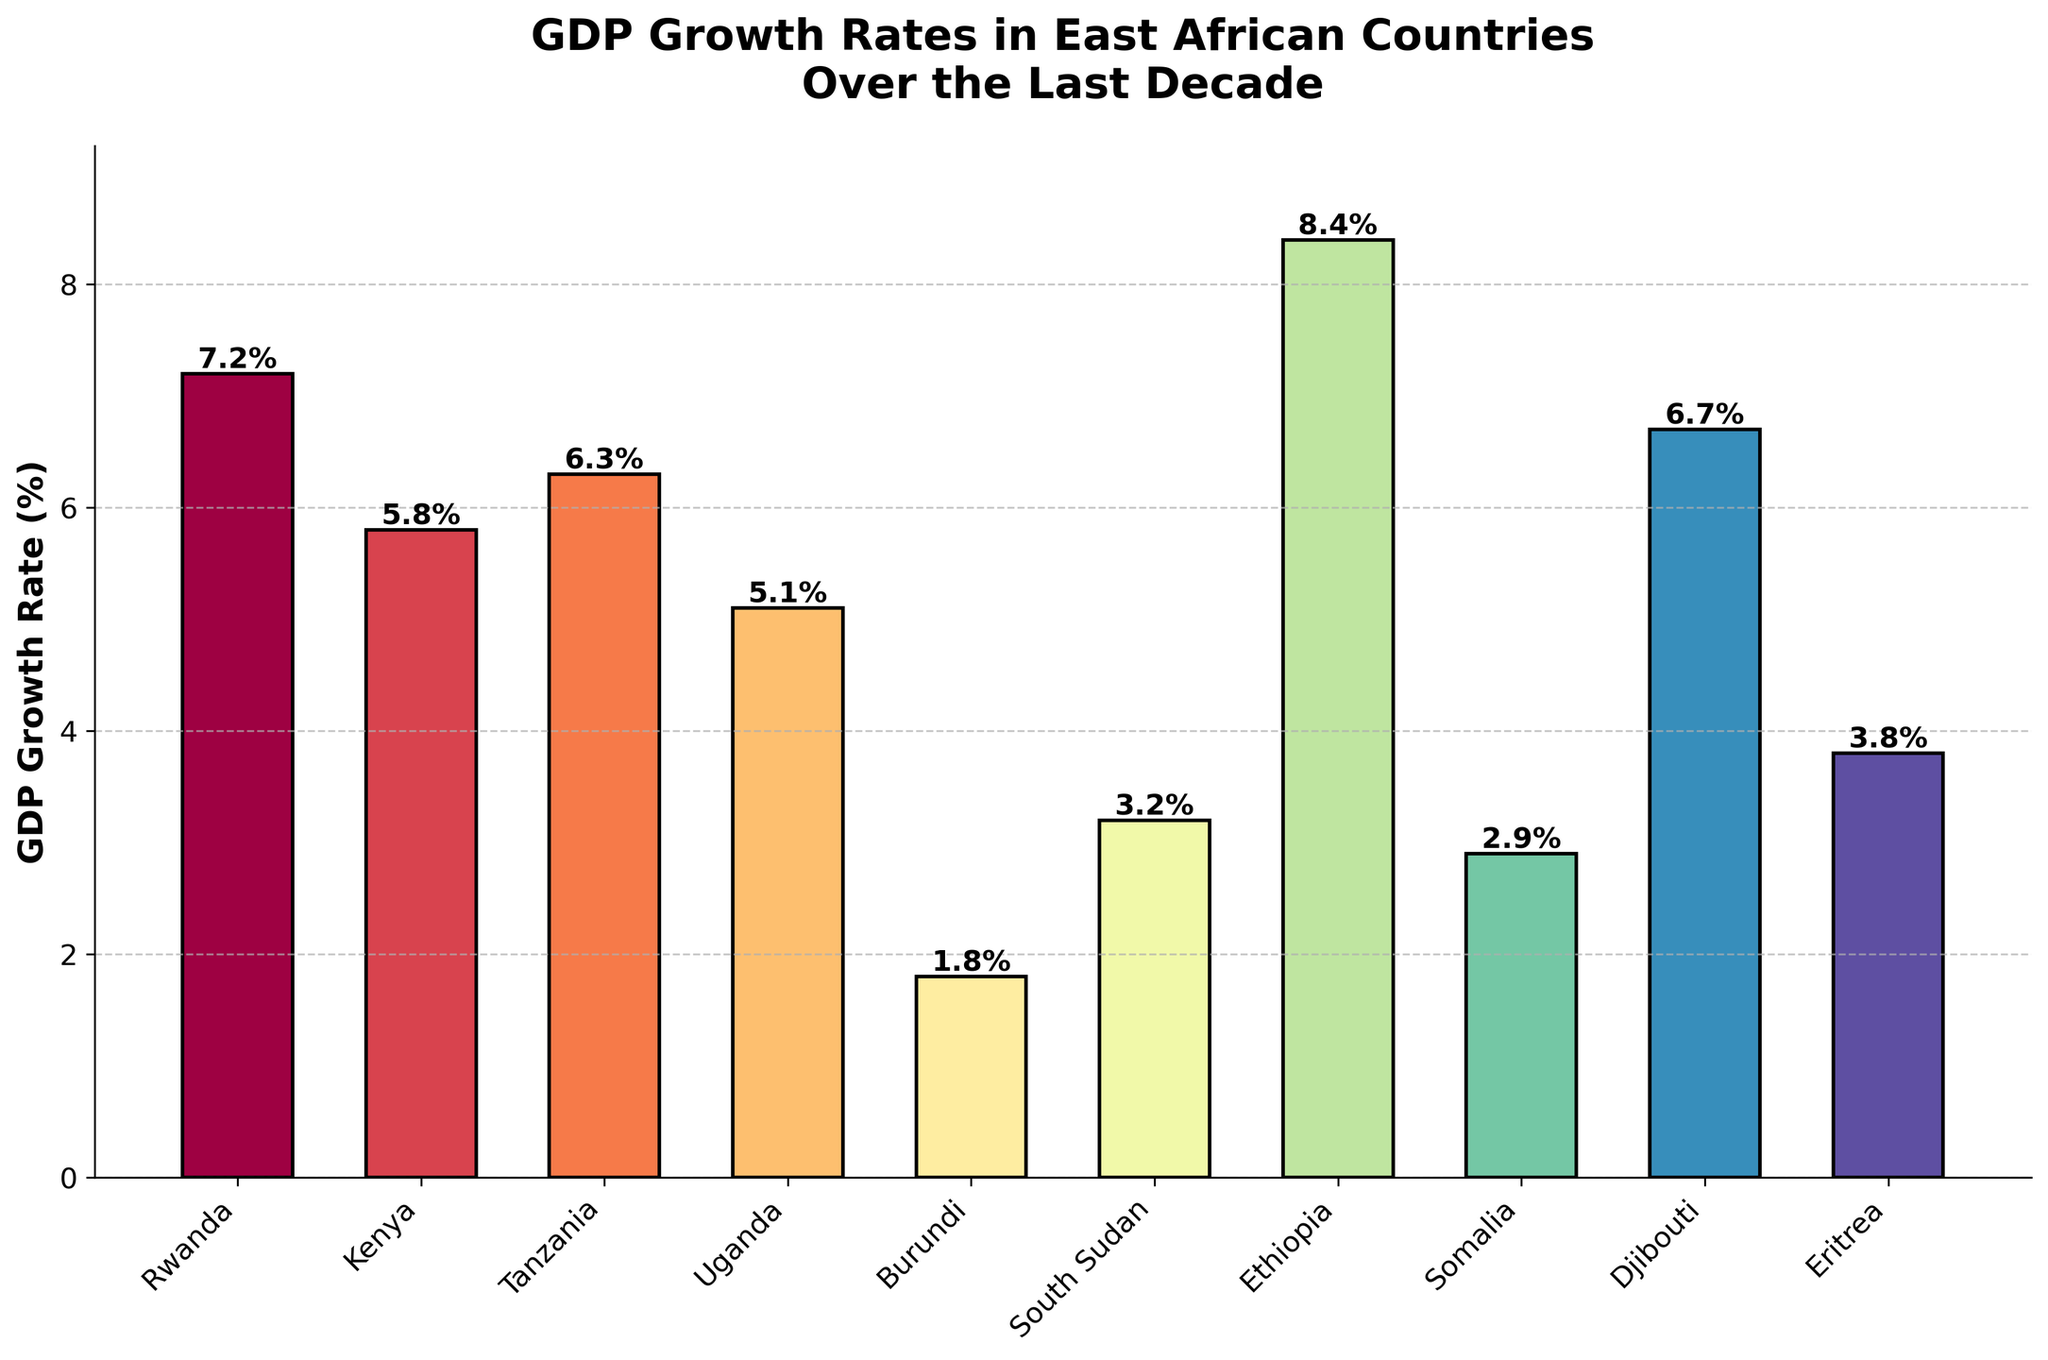Which country has the highest GDP growth rate? By observing the height of the bars in the chart and identifying which bar is the tallest, we can see that Ethiopia has the highest GDP growth rate.
Answer: Ethiopia Which country has the lowest GDP growth rate? By observing the height of the bars in the chart and identifying which bar is the shortest, we can see that Burundi has the lowest GDP growth rate.
Answer: Burundi Which countries have a GDP growth rate greater than 6%? By looking at the bars that extend above the 6% mark on the y-axis, we can identify Rwanda, Tanzania, Ethiopia, and Djibouti as the countries with a GDP growth rate greater than 6%.
Answer: Rwanda, Tanzania, Ethiopia, Djibouti By how much does Rwanda's GDP growth rate exceed Uganda's? Rwanda's GDP growth rate is 7.2% and Uganda's is 5.1%. Subtract Uganda's rate from Rwanda's to find the difference: 7.2 - 5.1 = 2.1%.
Answer: 2.1% What is the average GDP growth rate for these East African countries? Sum all the GDP growth rates and divide by the number of countries. (7.2 + 5.8 + 6.3 + 5.1 + 1.8 + 3.2 + 8.4 + 2.9 + 6.7 + 3.8) / 10 = 5.12%.
Answer: 5.12% Which country has a similar GDP growth rate to Somalia? By comparing the heights of the bars, Somalia (2.9%) has a GDP growth rate close to that of South Sudan (3.2%).
Answer: South Sudan Which country has a GDP growth rate less than 4% but higher than 2%? By comparing the heights of the bars and selecting the ones that fall between the 2% and 4% marks on the y-axis, we find that South Sudan (3.2%), Somalia (2.9%), and Eritrea (3.8%) meet this criterion.
Answer: South Sudan, Somalia, Eritrea How much higher is Ethiopia's GDP growth rate compared to Djibouti? Ethiopia has a GDP growth rate of 8.4%, and Djibouti has 6.7%. The difference is 8.4% - 6.7% = 1.7%.
Answer: 1.7% Which countries have a GDP growth rate within one percentage point of each other? By comparing the heights of all the bars, we see that Somalia (2.9%) and South Sudan (3.2%) have GDP growth rates within 0.3 percentage points of each other. Similarly, Eritrea (3.8%) and South Sudan (3.2%) have a difference of 0.6 percentage points.
Answer: Somalia and South Sudan, Eritrea and South Sudan Which country shows a GDP growth rate just above the midpoint between Burundi's and Ethiopia's growth rates? Burundi has a GDP growth rate of 1.8%, and Ethiopia has a GDP growth rate of 8.4%. The midpoint is (1.8 + 8.4)/2 = 5.1%. Uganda, with a GDP growth rate of 5.1%, is the country just above this midpoint.
Answer: Uganda 